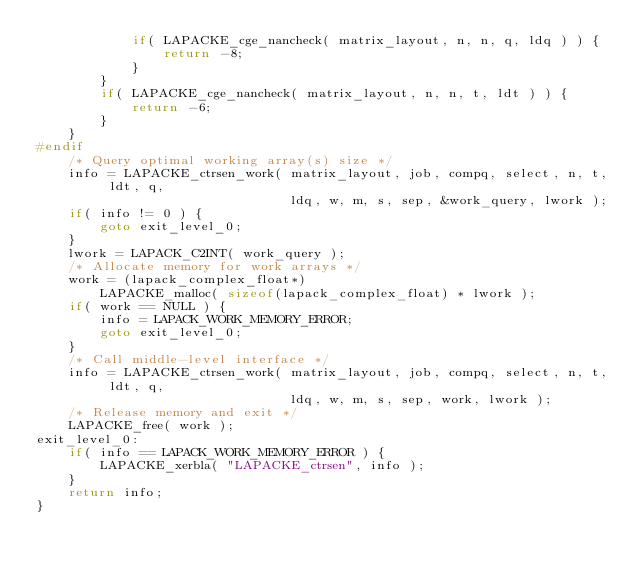Convert code to text. <code><loc_0><loc_0><loc_500><loc_500><_C_>            if( LAPACKE_cge_nancheck( matrix_layout, n, n, q, ldq ) ) {
                return -8;
            }
        }
        if( LAPACKE_cge_nancheck( matrix_layout, n, n, t, ldt ) ) {
            return -6;
        }
    }
#endif
    /* Query optimal working array(s) size */
    info = LAPACKE_ctrsen_work( matrix_layout, job, compq, select, n, t, ldt, q,
                                ldq, w, m, s, sep, &work_query, lwork );
    if( info != 0 ) {
        goto exit_level_0;
    }
    lwork = LAPACK_C2INT( work_query );
    /* Allocate memory for work arrays */
    work = (lapack_complex_float*)
        LAPACKE_malloc( sizeof(lapack_complex_float) * lwork );
    if( work == NULL ) {
        info = LAPACK_WORK_MEMORY_ERROR;
        goto exit_level_0;
    }
    /* Call middle-level interface */
    info = LAPACKE_ctrsen_work( matrix_layout, job, compq, select, n, t, ldt, q,
                                ldq, w, m, s, sep, work, lwork );
    /* Release memory and exit */
    LAPACKE_free( work );
exit_level_0:
    if( info == LAPACK_WORK_MEMORY_ERROR ) {
        LAPACKE_xerbla( "LAPACKE_ctrsen", info );
    }
    return info;
}
</code> 